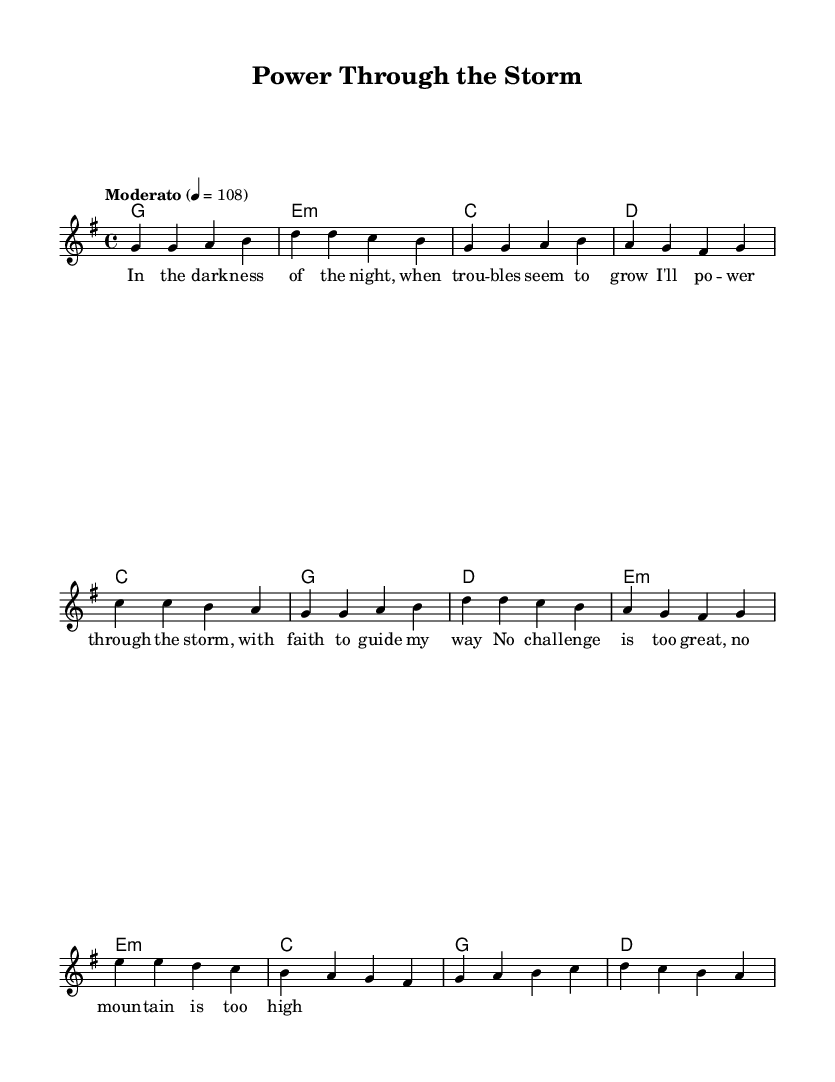What is the key signature of this music? The key signature is G major, which has one sharp (F#).
Answer: G major What is the time signature of the piece? The time signature is 4/4, indicating four beats per measure.
Answer: 4/4 What is the tempo marking given in the sheet music? The tempo marking is "Moderato," which suggests a moderate speed.
Answer: Moderato How many measures are in the verse section? The verse section consists of four measures, each with a specific melody and chord progression.
Answer: Four What is the main theme conveyed in the lyrics? The lyrics express themes of perseverance and spiritual strength during challenges.
Answer: Perseverance What harmony is used in the bridge section? The bridge section uses the chord progression, including E minor, C, G, and D.
Answer: E minor, C, G, D How many times is the chorus repeated? The chorus is repeated twice throughout the song structure, reinforcing its message.
Answer: Twice 